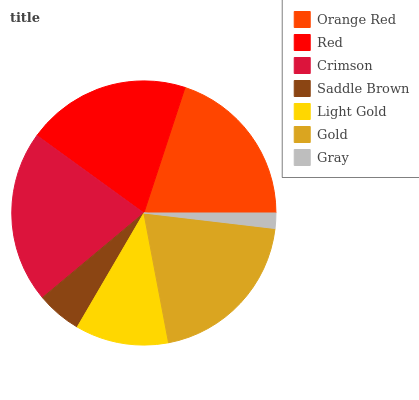Is Gray the minimum?
Answer yes or no. Yes. Is Crimson the maximum?
Answer yes or no. Yes. Is Red the minimum?
Answer yes or no. No. Is Red the maximum?
Answer yes or no. No. Is Red greater than Orange Red?
Answer yes or no. Yes. Is Orange Red less than Red?
Answer yes or no. Yes. Is Orange Red greater than Red?
Answer yes or no. No. Is Red less than Orange Red?
Answer yes or no. No. Is Orange Red the high median?
Answer yes or no. Yes. Is Orange Red the low median?
Answer yes or no. Yes. Is Saddle Brown the high median?
Answer yes or no. No. Is Light Gold the low median?
Answer yes or no. No. 